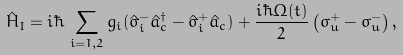<formula> <loc_0><loc_0><loc_500><loc_500>\, \hat { H } _ { I } = i \hbar { \, } \sum _ { i = 1 , 2 } g _ { i } ( \hat { \sigma } ^ { - } _ { i } \hat { a } ^ { \dagger } _ { c } - \hat { \sigma } ^ { + } _ { i } \hat { a } _ { c } ) + \frac { i \hbar { \Omega } ( t ) } { 2 } \left ( \sigma ^ { + } _ { u } - \sigma ^ { - } _ { u } \right ) ,</formula> 